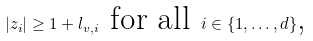Convert formula to latex. <formula><loc_0><loc_0><loc_500><loc_500>| z _ { i } | \geq 1 + l _ { v , i } \text { for all } i \in \{ 1 , \dots , d \} \text  ,</formula> 